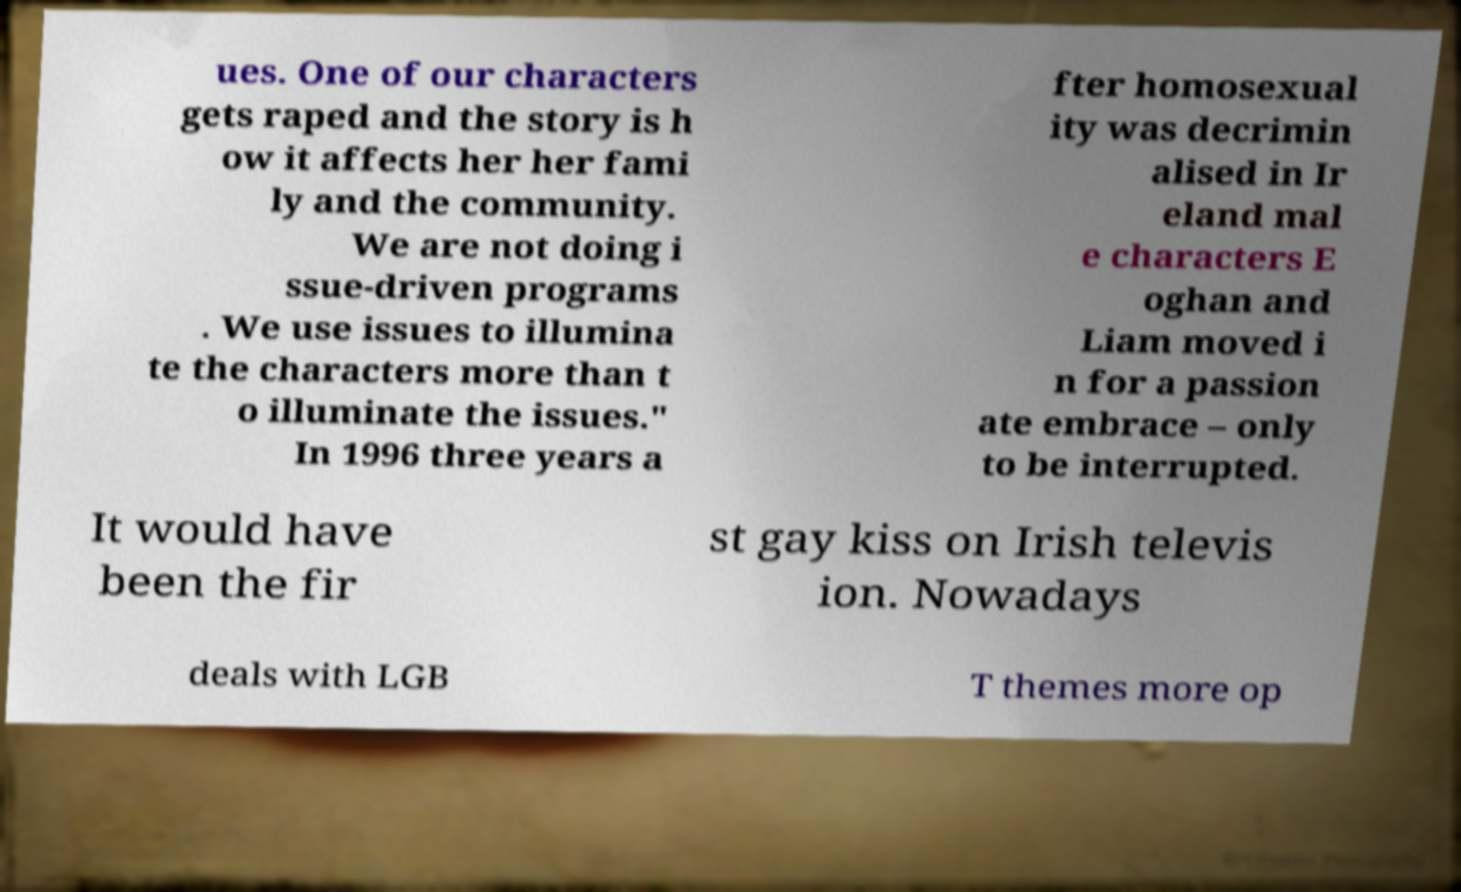There's text embedded in this image that I need extracted. Can you transcribe it verbatim? ues. One of our characters gets raped and the story is h ow it affects her her fami ly and the community. We are not doing i ssue-driven programs . We use issues to illumina te the characters more than t o illuminate the issues." In 1996 three years a fter homosexual ity was decrimin alised in Ir eland mal e characters E oghan and Liam moved i n for a passion ate embrace – only to be interrupted. It would have been the fir st gay kiss on Irish televis ion. Nowadays deals with LGB T themes more op 